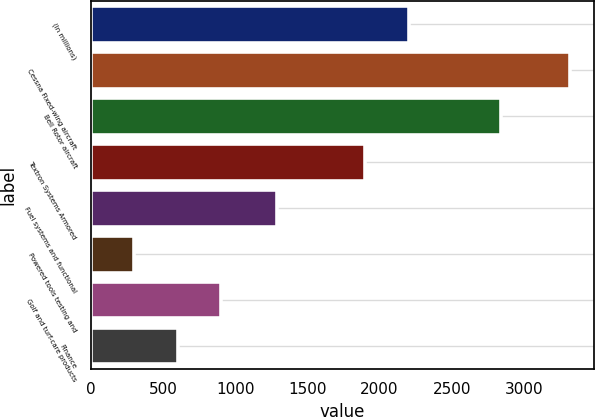Convert chart. <chart><loc_0><loc_0><loc_500><loc_500><bar_chart><fcel>(In millions)<fcel>Cessna Fixed-wing aircraft<fcel>Bell Rotor aircraft<fcel>Textron Systems Armored<fcel>Fuel systems and functional<fcel>Powered tools testing and<fcel>Golf and turf-care products<fcel>Finance<nl><fcel>2201<fcel>3320<fcel>2842<fcel>1899<fcel>1287<fcel>300<fcel>904<fcel>602<nl></chart> 